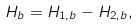<formula> <loc_0><loc_0><loc_500><loc_500>H _ { b } = H _ { 1 , b } - H _ { 2 , b } ,</formula> 